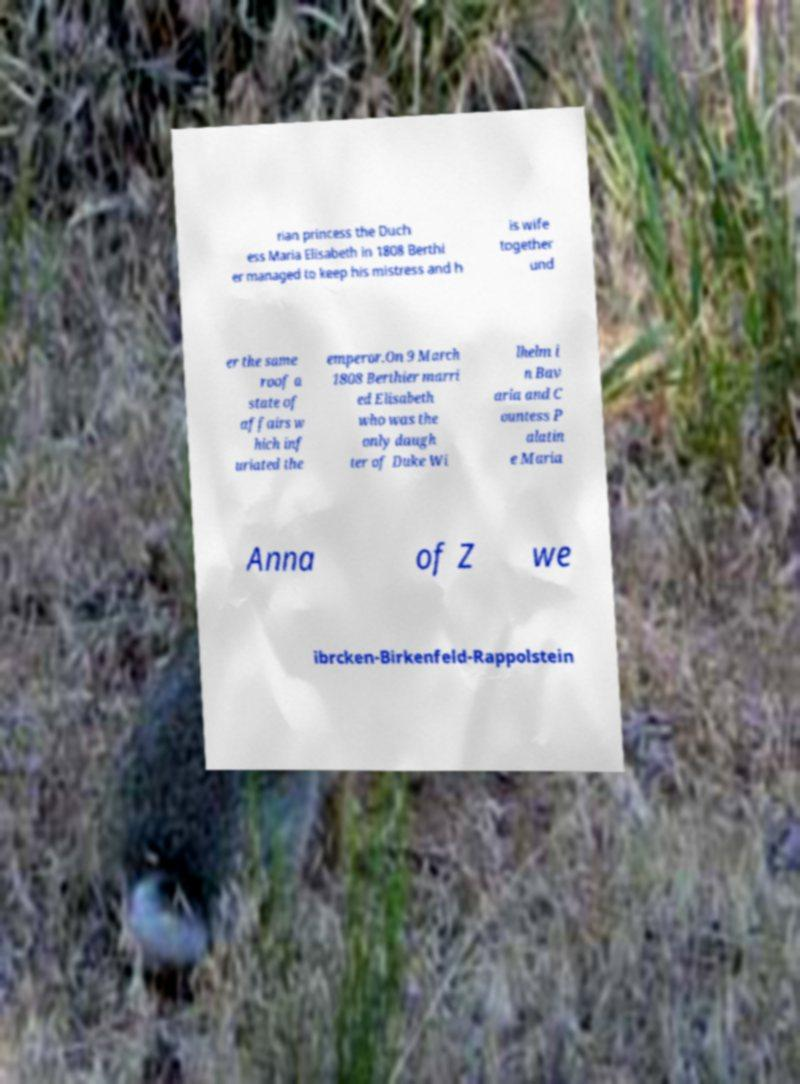Can you read and provide the text displayed in the image?This photo seems to have some interesting text. Can you extract and type it out for me? rian princess the Duch ess Maria Elisabeth in 1808 Berthi er managed to keep his mistress and h is wife together und er the same roof a state of affairs w hich inf uriated the emperor.On 9 March 1808 Berthier marri ed Elisabeth who was the only daugh ter of Duke Wi lhelm i n Bav aria and C ountess P alatin e Maria Anna of Z we ibrcken-Birkenfeld-Rappolstein 